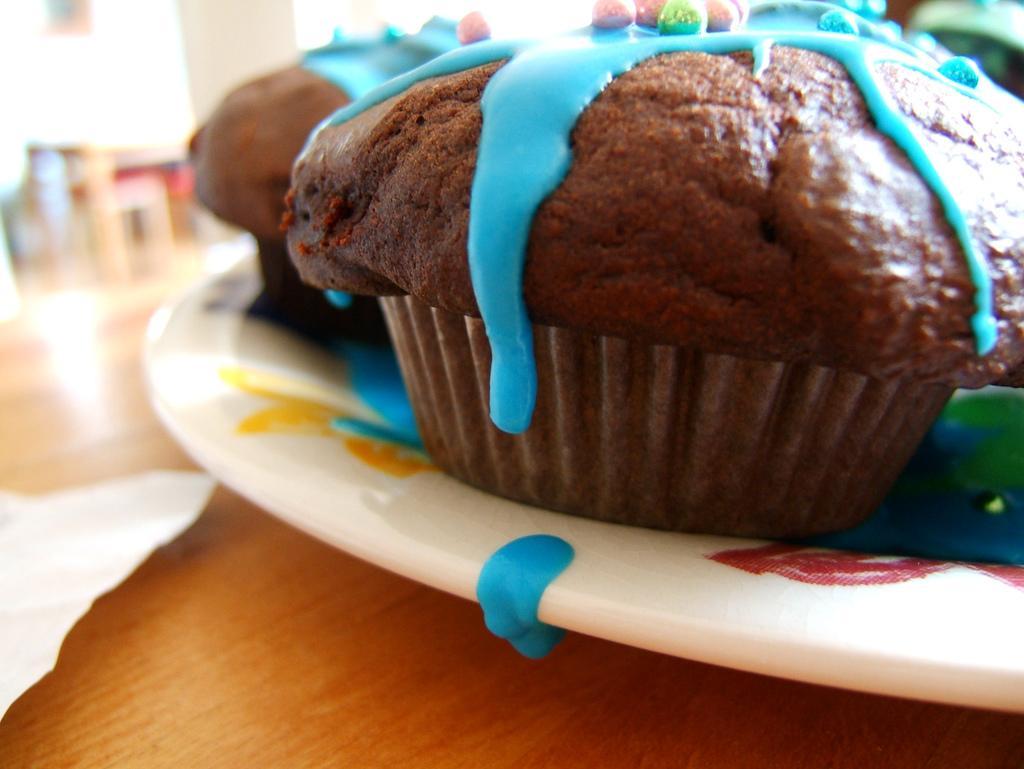In one or two sentences, can you explain what this image depicts? In this image we can see a plate of cupcakes. We can also see a tissue on the table and the background is blurred. 